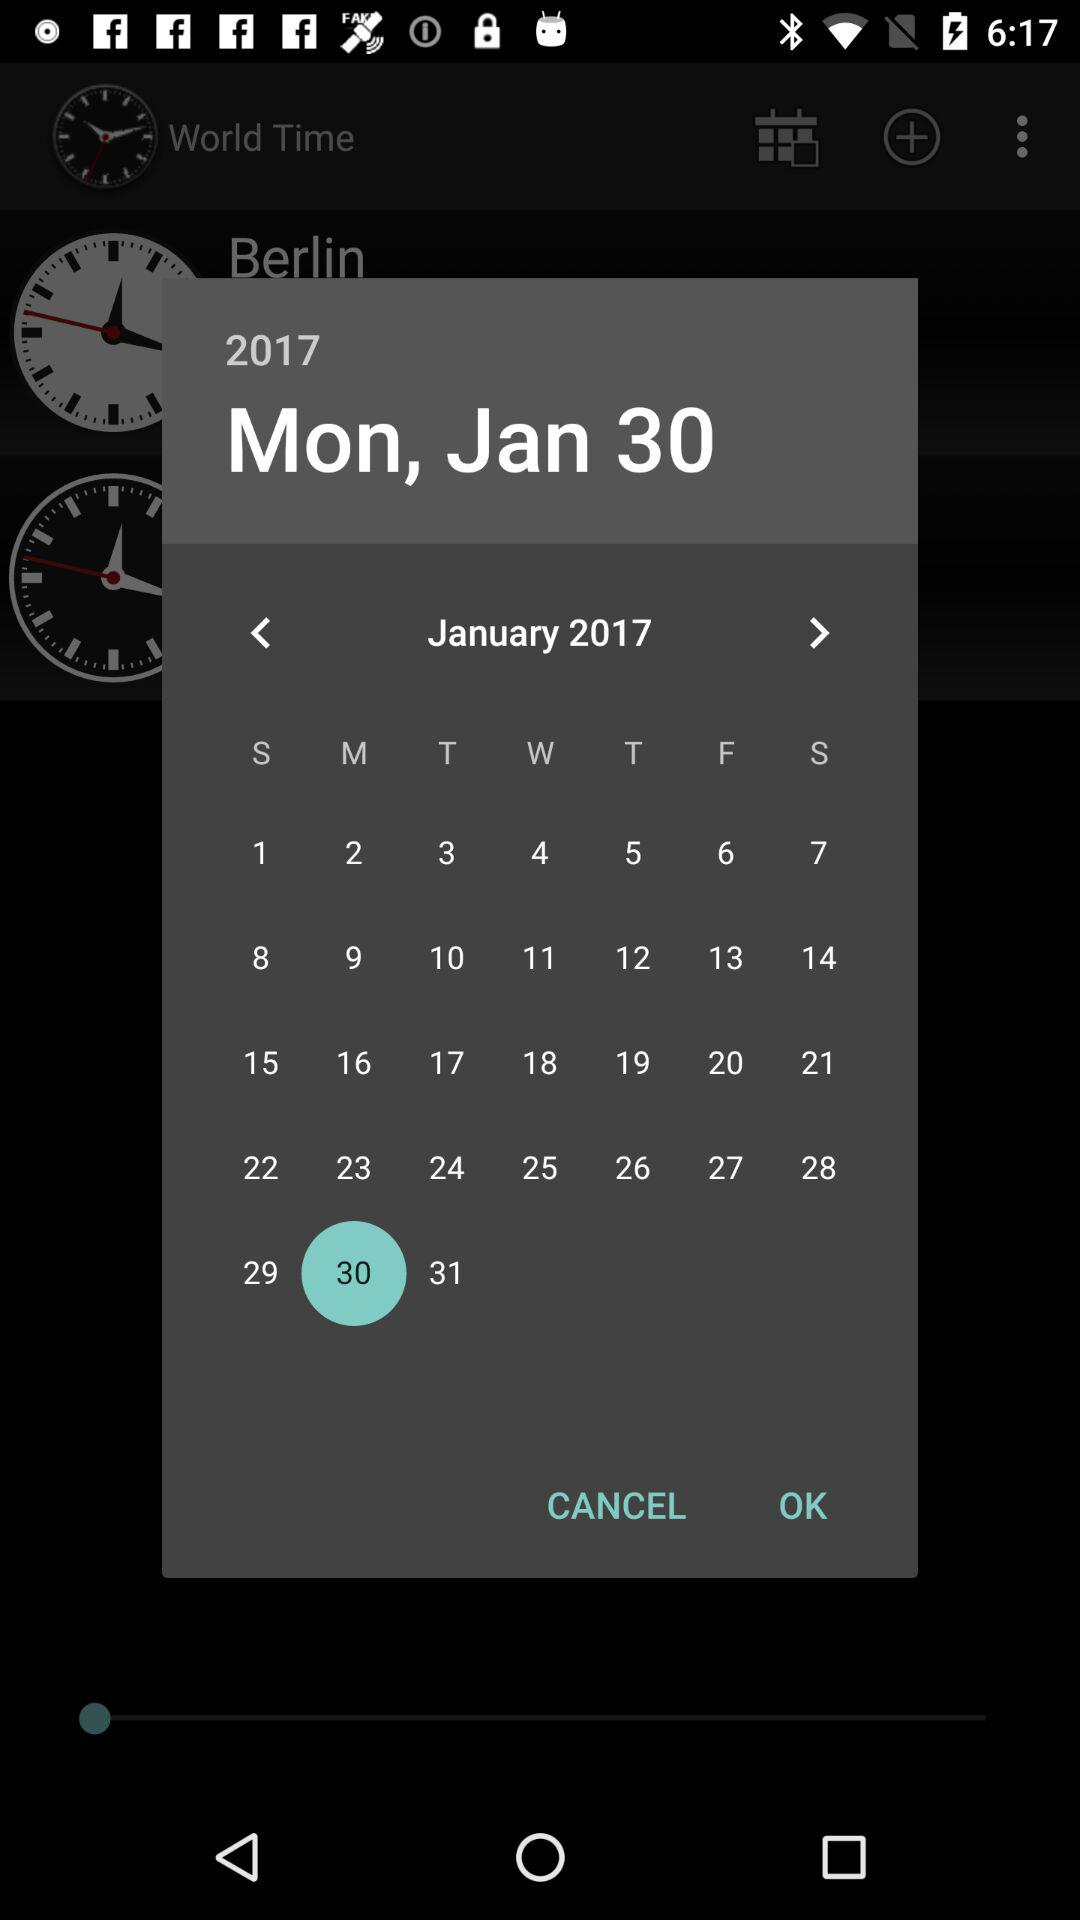What year is it? The year is 2017. 